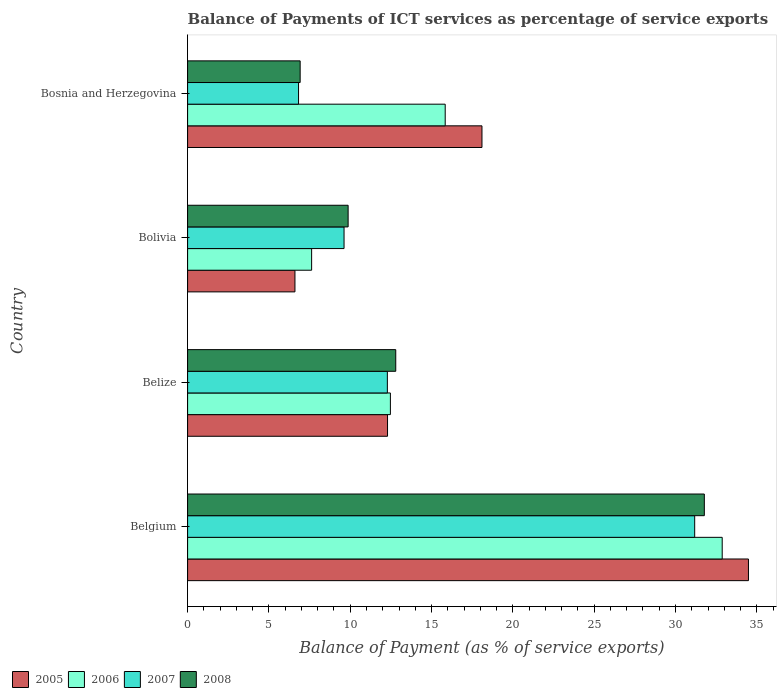Are the number of bars per tick equal to the number of legend labels?
Your response must be concise. Yes. Are the number of bars on each tick of the Y-axis equal?
Offer a terse response. Yes. How many bars are there on the 3rd tick from the top?
Your answer should be compact. 4. What is the label of the 3rd group of bars from the top?
Keep it short and to the point. Belize. In how many cases, is the number of bars for a given country not equal to the number of legend labels?
Make the answer very short. 0. What is the balance of payments of ICT services in 2008 in Bolivia?
Provide a short and direct response. 9.87. Across all countries, what is the maximum balance of payments of ICT services in 2007?
Give a very brief answer. 31.18. Across all countries, what is the minimum balance of payments of ICT services in 2008?
Provide a short and direct response. 6.92. In which country was the balance of payments of ICT services in 2008 maximum?
Your answer should be compact. Belgium. In which country was the balance of payments of ICT services in 2005 minimum?
Provide a succinct answer. Bolivia. What is the total balance of payments of ICT services in 2008 in the graph?
Offer a terse response. 61.36. What is the difference between the balance of payments of ICT services in 2006 in Bolivia and that in Bosnia and Herzegovina?
Your answer should be very brief. -8.21. What is the difference between the balance of payments of ICT services in 2008 in Bosnia and Herzegovina and the balance of payments of ICT services in 2006 in Belgium?
Provide a short and direct response. -25.95. What is the average balance of payments of ICT services in 2007 per country?
Offer a very short reply. 14.98. What is the difference between the balance of payments of ICT services in 2005 and balance of payments of ICT services in 2006 in Belize?
Your answer should be compact. -0.18. In how many countries, is the balance of payments of ICT services in 2006 greater than 20 %?
Ensure brevity in your answer.  1. What is the ratio of the balance of payments of ICT services in 2006 in Bolivia to that in Bosnia and Herzegovina?
Offer a very short reply. 0.48. Is the difference between the balance of payments of ICT services in 2005 in Belgium and Belize greater than the difference between the balance of payments of ICT services in 2006 in Belgium and Belize?
Make the answer very short. Yes. What is the difference between the highest and the second highest balance of payments of ICT services in 2008?
Keep it short and to the point. 18.97. What is the difference between the highest and the lowest balance of payments of ICT services in 2006?
Offer a terse response. 25.24. In how many countries, is the balance of payments of ICT services in 2006 greater than the average balance of payments of ICT services in 2006 taken over all countries?
Make the answer very short. 1. How many bars are there?
Your answer should be compact. 16. Are all the bars in the graph horizontal?
Give a very brief answer. Yes. How many countries are there in the graph?
Give a very brief answer. 4. Does the graph contain grids?
Provide a succinct answer. No. Where does the legend appear in the graph?
Your answer should be very brief. Bottom left. How are the legend labels stacked?
Provide a short and direct response. Horizontal. What is the title of the graph?
Your response must be concise. Balance of Payments of ICT services as percentage of service exports. Does "2011" appear as one of the legend labels in the graph?
Offer a terse response. No. What is the label or title of the X-axis?
Keep it short and to the point. Balance of Payment (as % of service exports). What is the label or title of the Y-axis?
Provide a succinct answer. Country. What is the Balance of Payment (as % of service exports) in 2005 in Belgium?
Your answer should be compact. 34.48. What is the Balance of Payment (as % of service exports) in 2006 in Belgium?
Your answer should be very brief. 32.87. What is the Balance of Payment (as % of service exports) in 2007 in Belgium?
Make the answer very short. 31.18. What is the Balance of Payment (as % of service exports) in 2008 in Belgium?
Your answer should be very brief. 31.77. What is the Balance of Payment (as % of service exports) of 2005 in Belize?
Offer a terse response. 12.29. What is the Balance of Payment (as % of service exports) in 2006 in Belize?
Your answer should be compact. 12.47. What is the Balance of Payment (as % of service exports) in 2007 in Belize?
Ensure brevity in your answer.  12.28. What is the Balance of Payment (as % of service exports) of 2008 in Belize?
Offer a very short reply. 12.8. What is the Balance of Payment (as % of service exports) in 2005 in Bolivia?
Give a very brief answer. 6.6. What is the Balance of Payment (as % of service exports) of 2006 in Bolivia?
Make the answer very short. 7.63. What is the Balance of Payment (as % of service exports) in 2007 in Bolivia?
Provide a short and direct response. 9.62. What is the Balance of Payment (as % of service exports) of 2008 in Bolivia?
Give a very brief answer. 9.87. What is the Balance of Payment (as % of service exports) of 2005 in Bosnia and Herzegovina?
Offer a terse response. 18.1. What is the Balance of Payment (as % of service exports) of 2006 in Bosnia and Herzegovina?
Offer a very short reply. 15.84. What is the Balance of Payment (as % of service exports) in 2007 in Bosnia and Herzegovina?
Keep it short and to the point. 6.82. What is the Balance of Payment (as % of service exports) in 2008 in Bosnia and Herzegovina?
Offer a very short reply. 6.92. Across all countries, what is the maximum Balance of Payment (as % of service exports) of 2005?
Provide a succinct answer. 34.48. Across all countries, what is the maximum Balance of Payment (as % of service exports) in 2006?
Ensure brevity in your answer.  32.87. Across all countries, what is the maximum Balance of Payment (as % of service exports) in 2007?
Provide a succinct answer. 31.18. Across all countries, what is the maximum Balance of Payment (as % of service exports) of 2008?
Your response must be concise. 31.77. Across all countries, what is the minimum Balance of Payment (as % of service exports) of 2005?
Provide a short and direct response. 6.6. Across all countries, what is the minimum Balance of Payment (as % of service exports) in 2006?
Provide a succinct answer. 7.63. Across all countries, what is the minimum Balance of Payment (as % of service exports) in 2007?
Ensure brevity in your answer.  6.82. Across all countries, what is the minimum Balance of Payment (as % of service exports) of 2008?
Your response must be concise. 6.92. What is the total Balance of Payment (as % of service exports) of 2005 in the graph?
Provide a succinct answer. 71.48. What is the total Balance of Payment (as % of service exports) in 2006 in the graph?
Provide a short and direct response. 68.81. What is the total Balance of Payment (as % of service exports) in 2007 in the graph?
Ensure brevity in your answer.  59.9. What is the total Balance of Payment (as % of service exports) of 2008 in the graph?
Provide a short and direct response. 61.36. What is the difference between the Balance of Payment (as % of service exports) of 2005 in Belgium and that in Belize?
Offer a very short reply. 22.19. What is the difference between the Balance of Payment (as % of service exports) in 2006 in Belgium and that in Belize?
Keep it short and to the point. 20.4. What is the difference between the Balance of Payment (as % of service exports) of 2007 in Belgium and that in Belize?
Ensure brevity in your answer.  18.9. What is the difference between the Balance of Payment (as % of service exports) of 2008 in Belgium and that in Belize?
Make the answer very short. 18.97. What is the difference between the Balance of Payment (as % of service exports) in 2005 in Belgium and that in Bolivia?
Keep it short and to the point. 27.88. What is the difference between the Balance of Payment (as % of service exports) of 2006 in Belgium and that in Bolivia?
Offer a terse response. 25.24. What is the difference between the Balance of Payment (as % of service exports) in 2007 in Belgium and that in Bolivia?
Provide a short and direct response. 21.56. What is the difference between the Balance of Payment (as % of service exports) of 2008 in Belgium and that in Bolivia?
Give a very brief answer. 21.9. What is the difference between the Balance of Payment (as % of service exports) in 2005 in Belgium and that in Bosnia and Herzegovina?
Give a very brief answer. 16.39. What is the difference between the Balance of Payment (as % of service exports) in 2006 in Belgium and that in Bosnia and Herzegovina?
Make the answer very short. 17.03. What is the difference between the Balance of Payment (as % of service exports) in 2007 in Belgium and that in Bosnia and Herzegovina?
Give a very brief answer. 24.36. What is the difference between the Balance of Payment (as % of service exports) in 2008 in Belgium and that in Bosnia and Herzegovina?
Keep it short and to the point. 24.85. What is the difference between the Balance of Payment (as % of service exports) in 2005 in Belize and that in Bolivia?
Offer a very short reply. 5.69. What is the difference between the Balance of Payment (as % of service exports) of 2006 in Belize and that in Bolivia?
Your answer should be compact. 4.84. What is the difference between the Balance of Payment (as % of service exports) of 2007 in Belize and that in Bolivia?
Provide a succinct answer. 2.66. What is the difference between the Balance of Payment (as % of service exports) of 2008 in Belize and that in Bolivia?
Ensure brevity in your answer.  2.93. What is the difference between the Balance of Payment (as % of service exports) in 2005 in Belize and that in Bosnia and Herzegovina?
Ensure brevity in your answer.  -5.81. What is the difference between the Balance of Payment (as % of service exports) of 2006 in Belize and that in Bosnia and Herzegovina?
Keep it short and to the point. -3.37. What is the difference between the Balance of Payment (as % of service exports) in 2007 in Belize and that in Bosnia and Herzegovina?
Give a very brief answer. 5.46. What is the difference between the Balance of Payment (as % of service exports) of 2008 in Belize and that in Bosnia and Herzegovina?
Your answer should be very brief. 5.88. What is the difference between the Balance of Payment (as % of service exports) in 2005 in Bolivia and that in Bosnia and Herzegovina?
Your response must be concise. -11.5. What is the difference between the Balance of Payment (as % of service exports) of 2006 in Bolivia and that in Bosnia and Herzegovina?
Offer a terse response. -8.21. What is the difference between the Balance of Payment (as % of service exports) in 2007 in Bolivia and that in Bosnia and Herzegovina?
Provide a short and direct response. 2.8. What is the difference between the Balance of Payment (as % of service exports) in 2008 in Bolivia and that in Bosnia and Herzegovina?
Offer a very short reply. 2.95. What is the difference between the Balance of Payment (as % of service exports) of 2005 in Belgium and the Balance of Payment (as % of service exports) of 2006 in Belize?
Provide a short and direct response. 22.02. What is the difference between the Balance of Payment (as % of service exports) in 2005 in Belgium and the Balance of Payment (as % of service exports) in 2007 in Belize?
Keep it short and to the point. 22.2. What is the difference between the Balance of Payment (as % of service exports) in 2005 in Belgium and the Balance of Payment (as % of service exports) in 2008 in Belize?
Ensure brevity in your answer.  21.69. What is the difference between the Balance of Payment (as % of service exports) in 2006 in Belgium and the Balance of Payment (as % of service exports) in 2007 in Belize?
Offer a terse response. 20.59. What is the difference between the Balance of Payment (as % of service exports) in 2006 in Belgium and the Balance of Payment (as % of service exports) in 2008 in Belize?
Give a very brief answer. 20.07. What is the difference between the Balance of Payment (as % of service exports) of 2007 in Belgium and the Balance of Payment (as % of service exports) of 2008 in Belize?
Offer a very short reply. 18.38. What is the difference between the Balance of Payment (as % of service exports) in 2005 in Belgium and the Balance of Payment (as % of service exports) in 2006 in Bolivia?
Your answer should be very brief. 26.86. What is the difference between the Balance of Payment (as % of service exports) in 2005 in Belgium and the Balance of Payment (as % of service exports) in 2007 in Bolivia?
Your answer should be compact. 24.87. What is the difference between the Balance of Payment (as % of service exports) of 2005 in Belgium and the Balance of Payment (as % of service exports) of 2008 in Bolivia?
Offer a very short reply. 24.61. What is the difference between the Balance of Payment (as % of service exports) in 2006 in Belgium and the Balance of Payment (as % of service exports) in 2007 in Bolivia?
Give a very brief answer. 23.25. What is the difference between the Balance of Payment (as % of service exports) in 2006 in Belgium and the Balance of Payment (as % of service exports) in 2008 in Bolivia?
Offer a terse response. 23. What is the difference between the Balance of Payment (as % of service exports) of 2007 in Belgium and the Balance of Payment (as % of service exports) of 2008 in Bolivia?
Offer a very short reply. 21.31. What is the difference between the Balance of Payment (as % of service exports) of 2005 in Belgium and the Balance of Payment (as % of service exports) of 2006 in Bosnia and Herzegovina?
Ensure brevity in your answer.  18.65. What is the difference between the Balance of Payment (as % of service exports) in 2005 in Belgium and the Balance of Payment (as % of service exports) in 2007 in Bosnia and Herzegovina?
Provide a succinct answer. 27.66. What is the difference between the Balance of Payment (as % of service exports) of 2005 in Belgium and the Balance of Payment (as % of service exports) of 2008 in Bosnia and Herzegovina?
Your response must be concise. 27.56. What is the difference between the Balance of Payment (as % of service exports) of 2006 in Belgium and the Balance of Payment (as % of service exports) of 2007 in Bosnia and Herzegovina?
Give a very brief answer. 26.05. What is the difference between the Balance of Payment (as % of service exports) of 2006 in Belgium and the Balance of Payment (as % of service exports) of 2008 in Bosnia and Herzegovina?
Ensure brevity in your answer.  25.95. What is the difference between the Balance of Payment (as % of service exports) of 2007 in Belgium and the Balance of Payment (as % of service exports) of 2008 in Bosnia and Herzegovina?
Your response must be concise. 24.26. What is the difference between the Balance of Payment (as % of service exports) in 2005 in Belize and the Balance of Payment (as % of service exports) in 2006 in Bolivia?
Make the answer very short. 4.67. What is the difference between the Balance of Payment (as % of service exports) in 2005 in Belize and the Balance of Payment (as % of service exports) in 2007 in Bolivia?
Your response must be concise. 2.67. What is the difference between the Balance of Payment (as % of service exports) in 2005 in Belize and the Balance of Payment (as % of service exports) in 2008 in Bolivia?
Offer a terse response. 2.42. What is the difference between the Balance of Payment (as % of service exports) of 2006 in Belize and the Balance of Payment (as % of service exports) of 2007 in Bolivia?
Keep it short and to the point. 2.85. What is the difference between the Balance of Payment (as % of service exports) of 2006 in Belize and the Balance of Payment (as % of service exports) of 2008 in Bolivia?
Your answer should be compact. 2.6. What is the difference between the Balance of Payment (as % of service exports) in 2007 in Belize and the Balance of Payment (as % of service exports) in 2008 in Bolivia?
Give a very brief answer. 2.41. What is the difference between the Balance of Payment (as % of service exports) in 2005 in Belize and the Balance of Payment (as % of service exports) in 2006 in Bosnia and Herzegovina?
Your response must be concise. -3.55. What is the difference between the Balance of Payment (as % of service exports) of 2005 in Belize and the Balance of Payment (as % of service exports) of 2007 in Bosnia and Herzegovina?
Your answer should be very brief. 5.47. What is the difference between the Balance of Payment (as % of service exports) of 2005 in Belize and the Balance of Payment (as % of service exports) of 2008 in Bosnia and Herzegovina?
Ensure brevity in your answer.  5.37. What is the difference between the Balance of Payment (as % of service exports) of 2006 in Belize and the Balance of Payment (as % of service exports) of 2007 in Bosnia and Herzegovina?
Provide a succinct answer. 5.65. What is the difference between the Balance of Payment (as % of service exports) of 2006 in Belize and the Balance of Payment (as % of service exports) of 2008 in Bosnia and Herzegovina?
Offer a terse response. 5.55. What is the difference between the Balance of Payment (as % of service exports) of 2007 in Belize and the Balance of Payment (as % of service exports) of 2008 in Bosnia and Herzegovina?
Your response must be concise. 5.36. What is the difference between the Balance of Payment (as % of service exports) in 2005 in Bolivia and the Balance of Payment (as % of service exports) in 2006 in Bosnia and Herzegovina?
Offer a terse response. -9.24. What is the difference between the Balance of Payment (as % of service exports) in 2005 in Bolivia and the Balance of Payment (as % of service exports) in 2007 in Bosnia and Herzegovina?
Provide a short and direct response. -0.22. What is the difference between the Balance of Payment (as % of service exports) in 2005 in Bolivia and the Balance of Payment (as % of service exports) in 2008 in Bosnia and Herzegovina?
Ensure brevity in your answer.  -0.32. What is the difference between the Balance of Payment (as % of service exports) of 2006 in Bolivia and the Balance of Payment (as % of service exports) of 2007 in Bosnia and Herzegovina?
Provide a short and direct response. 0.8. What is the difference between the Balance of Payment (as % of service exports) of 2006 in Bolivia and the Balance of Payment (as % of service exports) of 2008 in Bosnia and Herzegovina?
Your response must be concise. 0.71. What is the difference between the Balance of Payment (as % of service exports) in 2007 in Bolivia and the Balance of Payment (as % of service exports) in 2008 in Bosnia and Herzegovina?
Your answer should be very brief. 2.7. What is the average Balance of Payment (as % of service exports) of 2005 per country?
Make the answer very short. 17.87. What is the average Balance of Payment (as % of service exports) of 2006 per country?
Offer a terse response. 17.2. What is the average Balance of Payment (as % of service exports) of 2007 per country?
Offer a very short reply. 14.98. What is the average Balance of Payment (as % of service exports) in 2008 per country?
Offer a very short reply. 15.34. What is the difference between the Balance of Payment (as % of service exports) in 2005 and Balance of Payment (as % of service exports) in 2006 in Belgium?
Provide a succinct answer. 1.61. What is the difference between the Balance of Payment (as % of service exports) in 2005 and Balance of Payment (as % of service exports) in 2007 in Belgium?
Offer a terse response. 3.31. What is the difference between the Balance of Payment (as % of service exports) of 2005 and Balance of Payment (as % of service exports) of 2008 in Belgium?
Your answer should be very brief. 2.71. What is the difference between the Balance of Payment (as % of service exports) in 2006 and Balance of Payment (as % of service exports) in 2007 in Belgium?
Your answer should be compact. 1.69. What is the difference between the Balance of Payment (as % of service exports) in 2006 and Balance of Payment (as % of service exports) in 2008 in Belgium?
Provide a succinct answer. 1.1. What is the difference between the Balance of Payment (as % of service exports) in 2007 and Balance of Payment (as % of service exports) in 2008 in Belgium?
Provide a short and direct response. -0.59. What is the difference between the Balance of Payment (as % of service exports) of 2005 and Balance of Payment (as % of service exports) of 2006 in Belize?
Offer a terse response. -0.18. What is the difference between the Balance of Payment (as % of service exports) in 2005 and Balance of Payment (as % of service exports) in 2007 in Belize?
Your response must be concise. 0.01. What is the difference between the Balance of Payment (as % of service exports) of 2005 and Balance of Payment (as % of service exports) of 2008 in Belize?
Your response must be concise. -0.5. What is the difference between the Balance of Payment (as % of service exports) of 2006 and Balance of Payment (as % of service exports) of 2007 in Belize?
Make the answer very short. 0.19. What is the difference between the Balance of Payment (as % of service exports) in 2006 and Balance of Payment (as % of service exports) in 2008 in Belize?
Your answer should be very brief. -0.33. What is the difference between the Balance of Payment (as % of service exports) in 2007 and Balance of Payment (as % of service exports) in 2008 in Belize?
Your answer should be very brief. -0.52. What is the difference between the Balance of Payment (as % of service exports) in 2005 and Balance of Payment (as % of service exports) in 2006 in Bolivia?
Keep it short and to the point. -1.03. What is the difference between the Balance of Payment (as % of service exports) in 2005 and Balance of Payment (as % of service exports) in 2007 in Bolivia?
Provide a short and direct response. -3.02. What is the difference between the Balance of Payment (as % of service exports) of 2005 and Balance of Payment (as % of service exports) of 2008 in Bolivia?
Ensure brevity in your answer.  -3.27. What is the difference between the Balance of Payment (as % of service exports) in 2006 and Balance of Payment (as % of service exports) in 2007 in Bolivia?
Offer a very short reply. -1.99. What is the difference between the Balance of Payment (as % of service exports) in 2006 and Balance of Payment (as % of service exports) in 2008 in Bolivia?
Make the answer very short. -2.24. What is the difference between the Balance of Payment (as % of service exports) of 2007 and Balance of Payment (as % of service exports) of 2008 in Bolivia?
Your answer should be very brief. -0.25. What is the difference between the Balance of Payment (as % of service exports) of 2005 and Balance of Payment (as % of service exports) of 2006 in Bosnia and Herzegovina?
Your answer should be compact. 2.26. What is the difference between the Balance of Payment (as % of service exports) of 2005 and Balance of Payment (as % of service exports) of 2007 in Bosnia and Herzegovina?
Offer a very short reply. 11.28. What is the difference between the Balance of Payment (as % of service exports) in 2005 and Balance of Payment (as % of service exports) in 2008 in Bosnia and Herzegovina?
Give a very brief answer. 11.18. What is the difference between the Balance of Payment (as % of service exports) in 2006 and Balance of Payment (as % of service exports) in 2007 in Bosnia and Herzegovina?
Your answer should be very brief. 9.02. What is the difference between the Balance of Payment (as % of service exports) in 2006 and Balance of Payment (as % of service exports) in 2008 in Bosnia and Herzegovina?
Keep it short and to the point. 8.92. What is the difference between the Balance of Payment (as % of service exports) in 2007 and Balance of Payment (as % of service exports) in 2008 in Bosnia and Herzegovina?
Your response must be concise. -0.1. What is the ratio of the Balance of Payment (as % of service exports) in 2005 in Belgium to that in Belize?
Your answer should be very brief. 2.81. What is the ratio of the Balance of Payment (as % of service exports) in 2006 in Belgium to that in Belize?
Your answer should be compact. 2.64. What is the ratio of the Balance of Payment (as % of service exports) of 2007 in Belgium to that in Belize?
Give a very brief answer. 2.54. What is the ratio of the Balance of Payment (as % of service exports) of 2008 in Belgium to that in Belize?
Offer a terse response. 2.48. What is the ratio of the Balance of Payment (as % of service exports) in 2005 in Belgium to that in Bolivia?
Your answer should be very brief. 5.22. What is the ratio of the Balance of Payment (as % of service exports) in 2006 in Belgium to that in Bolivia?
Offer a terse response. 4.31. What is the ratio of the Balance of Payment (as % of service exports) in 2007 in Belgium to that in Bolivia?
Ensure brevity in your answer.  3.24. What is the ratio of the Balance of Payment (as % of service exports) in 2008 in Belgium to that in Bolivia?
Offer a very short reply. 3.22. What is the ratio of the Balance of Payment (as % of service exports) in 2005 in Belgium to that in Bosnia and Herzegovina?
Keep it short and to the point. 1.91. What is the ratio of the Balance of Payment (as % of service exports) in 2006 in Belgium to that in Bosnia and Herzegovina?
Keep it short and to the point. 2.08. What is the ratio of the Balance of Payment (as % of service exports) of 2007 in Belgium to that in Bosnia and Herzegovina?
Your answer should be compact. 4.57. What is the ratio of the Balance of Payment (as % of service exports) of 2008 in Belgium to that in Bosnia and Herzegovina?
Keep it short and to the point. 4.59. What is the ratio of the Balance of Payment (as % of service exports) of 2005 in Belize to that in Bolivia?
Your answer should be compact. 1.86. What is the ratio of the Balance of Payment (as % of service exports) in 2006 in Belize to that in Bolivia?
Offer a terse response. 1.64. What is the ratio of the Balance of Payment (as % of service exports) in 2007 in Belize to that in Bolivia?
Offer a terse response. 1.28. What is the ratio of the Balance of Payment (as % of service exports) of 2008 in Belize to that in Bolivia?
Your answer should be very brief. 1.3. What is the ratio of the Balance of Payment (as % of service exports) in 2005 in Belize to that in Bosnia and Herzegovina?
Ensure brevity in your answer.  0.68. What is the ratio of the Balance of Payment (as % of service exports) of 2006 in Belize to that in Bosnia and Herzegovina?
Offer a terse response. 0.79. What is the ratio of the Balance of Payment (as % of service exports) in 2007 in Belize to that in Bosnia and Herzegovina?
Offer a very short reply. 1.8. What is the ratio of the Balance of Payment (as % of service exports) of 2008 in Belize to that in Bosnia and Herzegovina?
Provide a succinct answer. 1.85. What is the ratio of the Balance of Payment (as % of service exports) of 2005 in Bolivia to that in Bosnia and Herzegovina?
Provide a short and direct response. 0.36. What is the ratio of the Balance of Payment (as % of service exports) of 2006 in Bolivia to that in Bosnia and Herzegovina?
Offer a terse response. 0.48. What is the ratio of the Balance of Payment (as % of service exports) of 2007 in Bolivia to that in Bosnia and Herzegovina?
Keep it short and to the point. 1.41. What is the ratio of the Balance of Payment (as % of service exports) in 2008 in Bolivia to that in Bosnia and Herzegovina?
Your answer should be very brief. 1.43. What is the difference between the highest and the second highest Balance of Payment (as % of service exports) in 2005?
Make the answer very short. 16.39. What is the difference between the highest and the second highest Balance of Payment (as % of service exports) of 2006?
Your response must be concise. 17.03. What is the difference between the highest and the second highest Balance of Payment (as % of service exports) of 2007?
Keep it short and to the point. 18.9. What is the difference between the highest and the second highest Balance of Payment (as % of service exports) in 2008?
Provide a short and direct response. 18.97. What is the difference between the highest and the lowest Balance of Payment (as % of service exports) of 2005?
Ensure brevity in your answer.  27.88. What is the difference between the highest and the lowest Balance of Payment (as % of service exports) in 2006?
Provide a succinct answer. 25.24. What is the difference between the highest and the lowest Balance of Payment (as % of service exports) of 2007?
Provide a short and direct response. 24.36. What is the difference between the highest and the lowest Balance of Payment (as % of service exports) of 2008?
Offer a terse response. 24.85. 